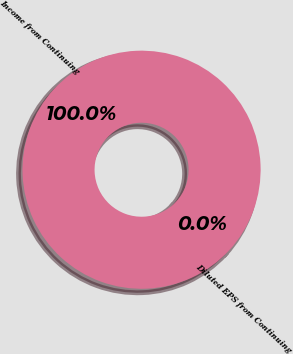<chart> <loc_0><loc_0><loc_500><loc_500><pie_chart><fcel>Income from Continuing<fcel>Diluted EPS from Continuing<nl><fcel>100.0%<fcel>0.0%<nl></chart> 